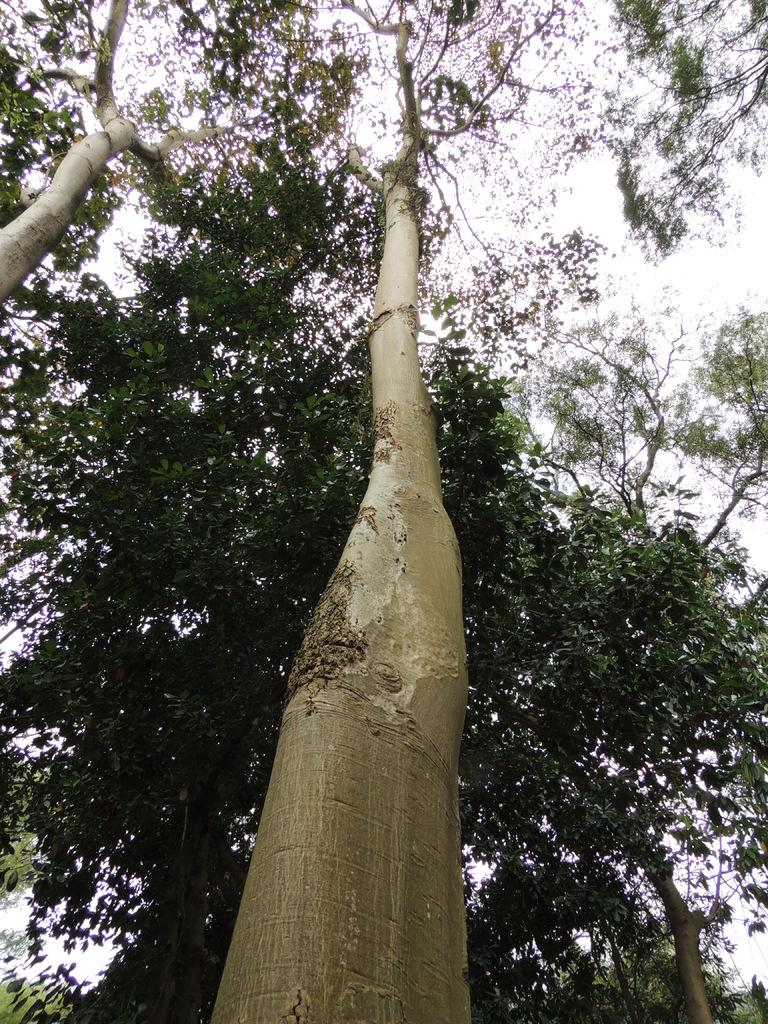What type of vegetation can be seen in the image? The image contains trees. What part of the natural environment is visible in the image? The sky is visible in the background of the image. What type of work is being done in the image? There is no indication of work being done in the image; it primarily features trees and the sky. 